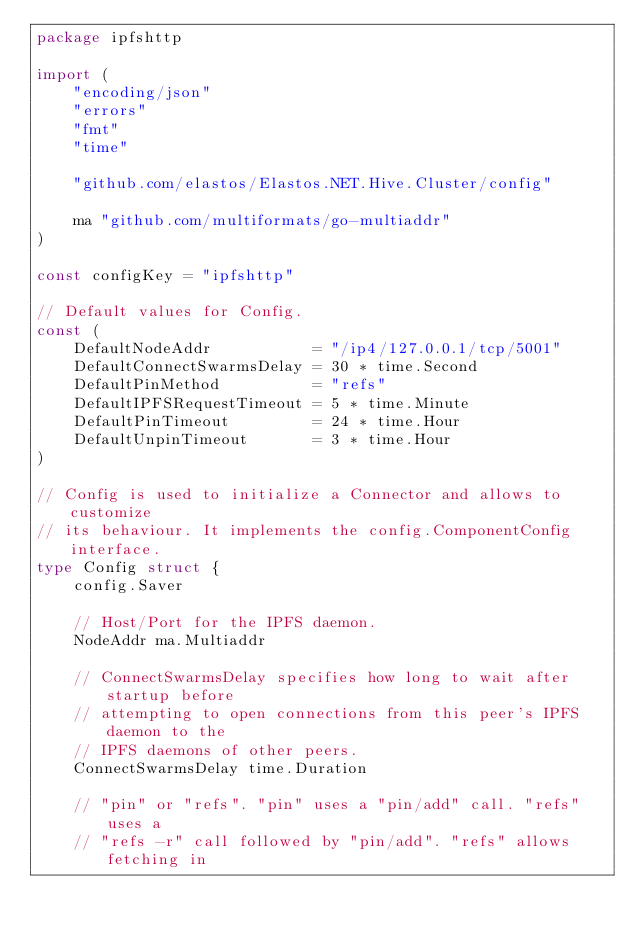<code> <loc_0><loc_0><loc_500><loc_500><_Go_>package ipfshttp

import (
	"encoding/json"
	"errors"
	"fmt"
	"time"

	"github.com/elastos/Elastos.NET.Hive.Cluster/config"

	ma "github.com/multiformats/go-multiaddr"
)

const configKey = "ipfshttp"

// Default values for Config.
const (
	DefaultNodeAddr           = "/ip4/127.0.0.1/tcp/5001"
	DefaultConnectSwarmsDelay = 30 * time.Second
	DefaultPinMethod          = "refs"
	DefaultIPFSRequestTimeout = 5 * time.Minute
	DefaultPinTimeout         = 24 * time.Hour
	DefaultUnpinTimeout       = 3 * time.Hour
)

// Config is used to initialize a Connector and allows to customize
// its behaviour. It implements the config.ComponentConfig interface.
type Config struct {
	config.Saver

	// Host/Port for the IPFS daemon.
	NodeAddr ma.Multiaddr

	// ConnectSwarmsDelay specifies how long to wait after startup before
	// attempting to open connections from this peer's IPFS daemon to the
	// IPFS daemons of other peers.
	ConnectSwarmsDelay time.Duration

	// "pin" or "refs". "pin" uses a "pin/add" call. "refs" uses a
	// "refs -r" call followed by "pin/add". "refs" allows fetching in</code> 